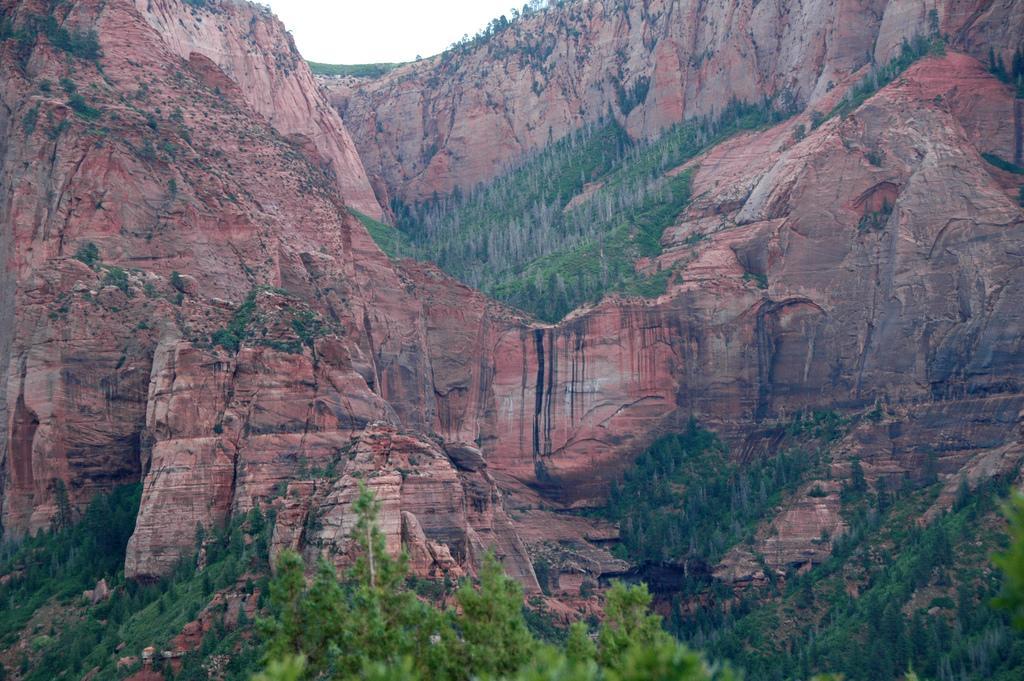Please provide a concise description of this image. In this image there are trees and there are rocks. 